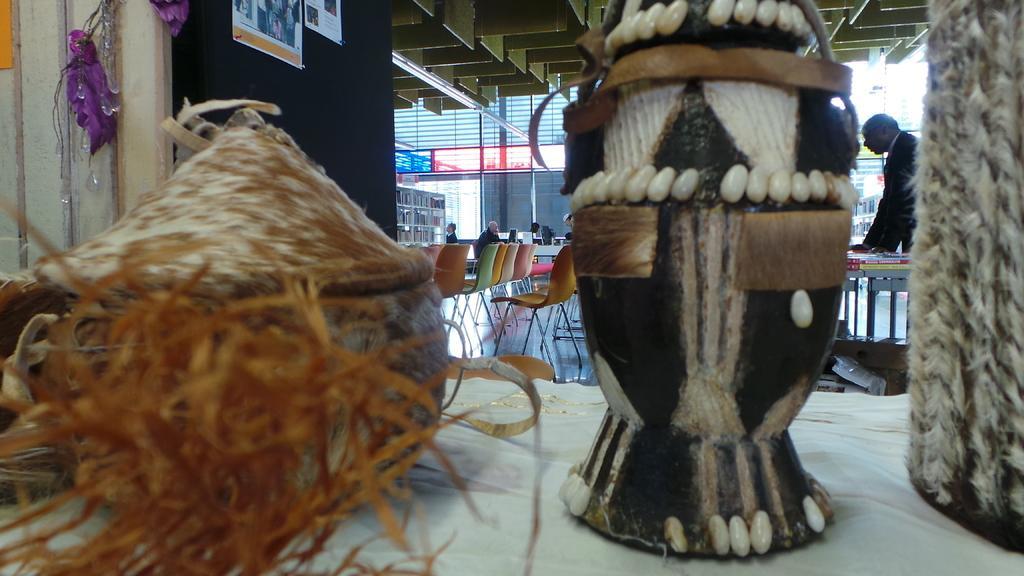Can you describe this image briefly? In the foreground I can see handicrafts on the table. In the background I can see chairs, tables, crowd and buildings. This image is taken in a restaurant. 